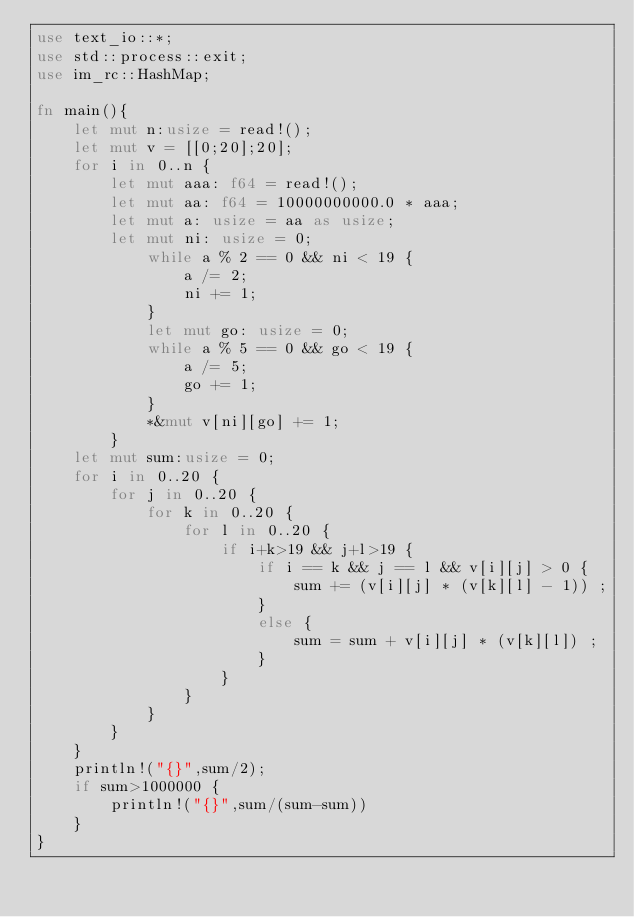Convert code to text. <code><loc_0><loc_0><loc_500><loc_500><_Rust_>use text_io::*;
use std::process::exit;
use im_rc::HashMap;

fn main(){
    let mut n:usize = read!();
    let mut v = [[0;20];20];
    for i in 0..n {
        let mut aaa: f64 = read!();
        let mut aa: f64 = 10000000000.0 * aaa;
        let mut a: usize = aa as usize;
        let mut ni: usize = 0;
            while a % 2 == 0 && ni < 19 {
                a /= 2;
                ni += 1;
            }
            let mut go: usize = 0;
            while a % 5 == 0 && go < 19 {
                a /= 5;
                go += 1;
            }
            *&mut v[ni][go] += 1;
        }
    let mut sum:usize = 0;
    for i in 0..20 {
        for j in 0..20 {
            for k in 0..20 {
                for l in 0..20 {
                    if i+k>19 && j+l>19 {
                        if i == k && j == l && v[i][j] > 0 {
                            sum += (v[i][j] * (v[k][l] - 1)) ;
                        }
                        else {
                            sum = sum + v[i][j] * (v[k][l]) ;
                        }
                    }
                }
            }
        }
    }
    println!("{}",sum/2);
    if sum>1000000 {
        println!("{}",sum/(sum-sum))
    }
}</code> 